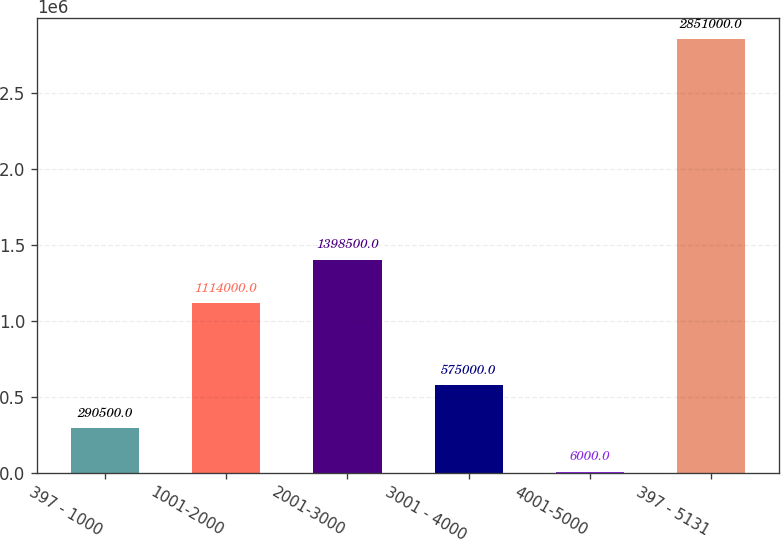<chart> <loc_0><loc_0><loc_500><loc_500><bar_chart><fcel>397 - 1000<fcel>1001-2000<fcel>2001-3000<fcel>3001 - 4000<fcel>4001-5000<fcel>397 - 5131<nl><fcel>290500<fcel>1.114e+06<fcel>1.3985e+06<fcel>575000<fcel>6000<fcel>2.851e+06<nl></chart> 